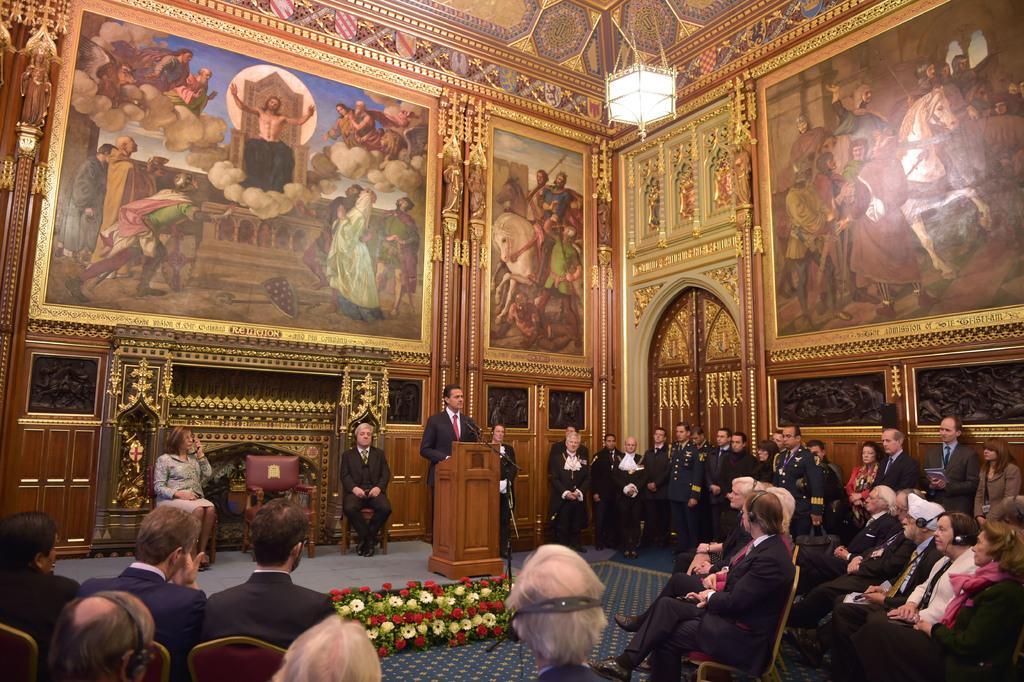How would you summarize this image in a sentence or two? In the picture we can see some group of persons sitting on chairs, some are standing, there is a person standing behind podium on which there is a microphone and there are some flowers on ground and in the background there is a wall which is painted with different pictures. 